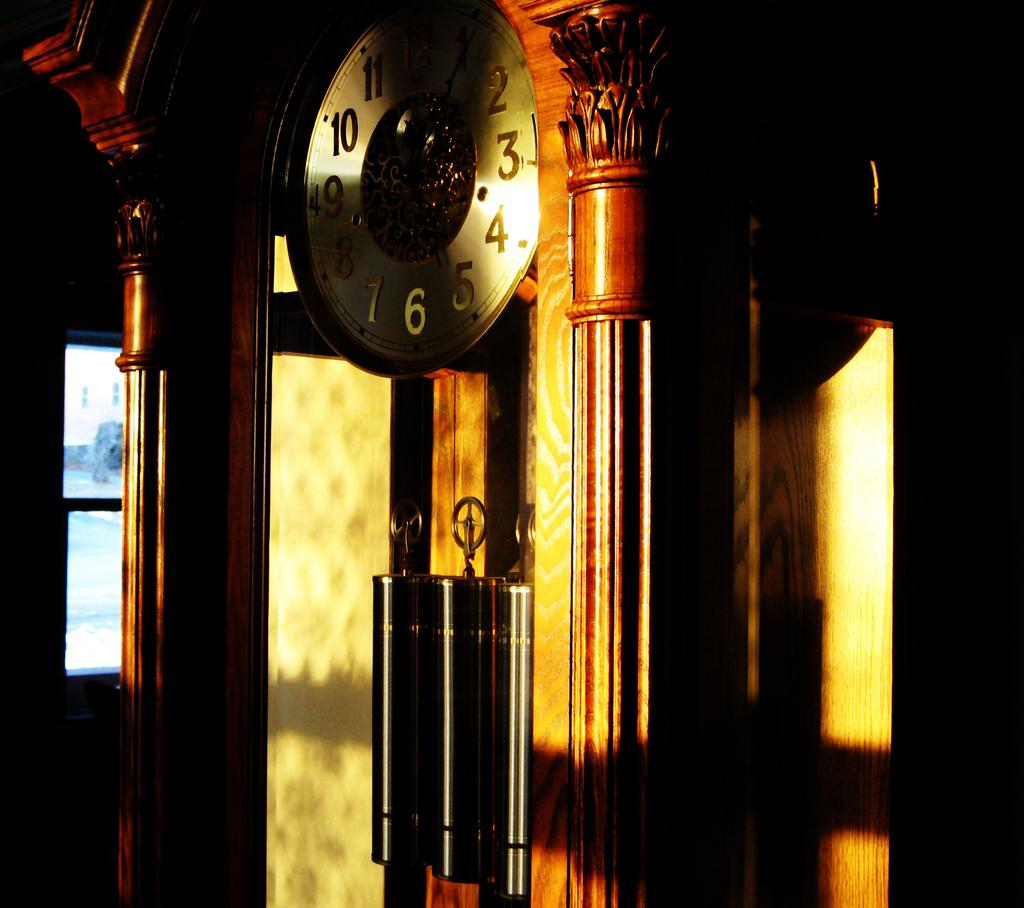Provide a one-sentence caption for the provided image. On a clock, the numbers 10 and 4 are caught in a bright sunbeam. 